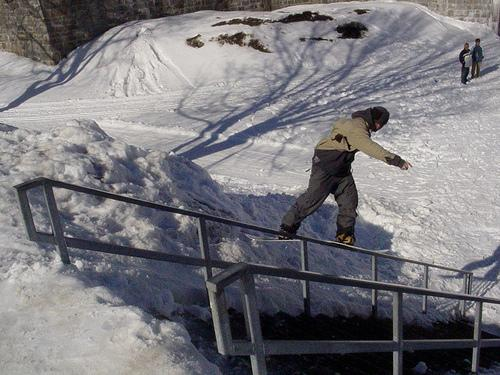What move is the snowboarder doing?

Choices:
A) grind
B) nose grab
C) kickflip
D) indy grind 